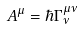<formula> <loc_0><loc_0><loc_500><loc_500>A ^ { \mu } = \hbar { \Gamma } _ { \nu } ^ { \mu \nu }</formula> 